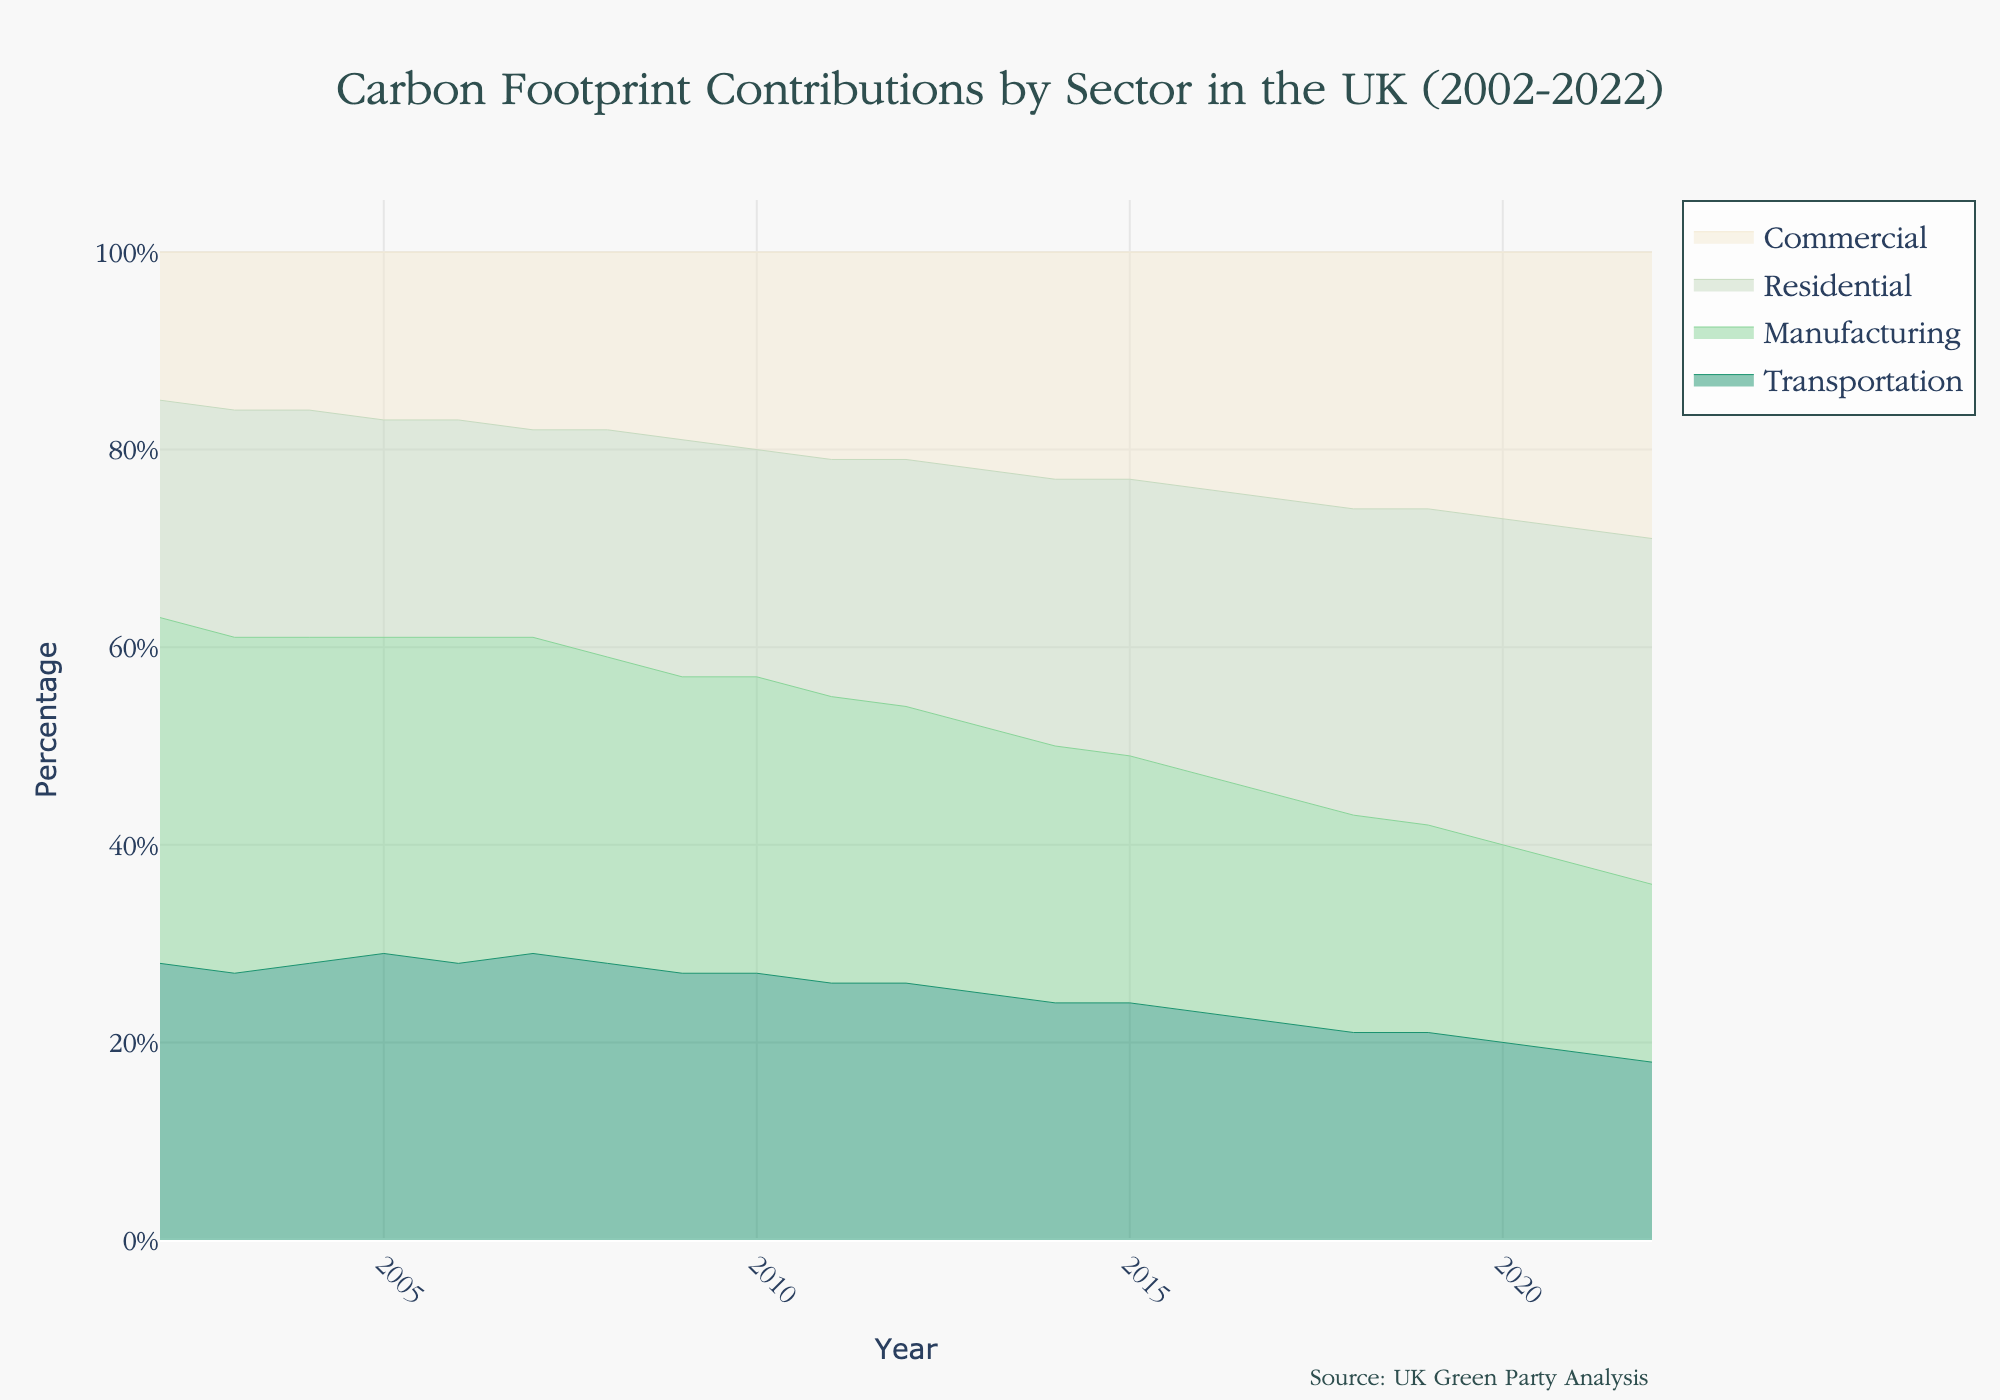what is the title of the figure? The title is displayed at the top center of the figure. It reads "Carbon Footprint Contributions by Sector in the UK (2002-2022)".
Answer: Carbon Footprint Contributions by Sector in the UK (2002-2022) What is the percentage of the Transportation sector in 2002? Locate the Transportation sector (the bottommost area) for the year 2002 on the x-axis. The height of this area relative to the total height is about 28%.
Answer: 28% Which sector showed the most considerable increase in contribution over the period? By observing the stacked areas from 2002 to 2022, the Residential sector shows a noticeable increase in its area, indicating a significant rise in its contribution.
Answer: Residential Between which years did the Manufacturing sector’s contribution drop the most? Look at the Manufacturing sector's area size across the years. The most significant drop occurs between 2005 (32%) and 2022 (18%).
Answer: 2005 to 2022 In which year did the Residential sector's percentage first surpass that of the Transportation sector? Track the crossover point where the area representing Residential becomes larger than Transportation. This happens in 2013.
Answer: 2013 What was the combined contribution of Commercial and Residential sectors in 2015? Add the individual percentages of the Commercial sector (23%) and Residential sector (28%) for 2015. The sum is 23% + 28% = 51%.
Answer: 51% How did the total contribution of all sectors in 2010 compare to that in 2015? Both years will sum to 100% as it is a 100% Stacked Area Chart. Thus, the total is the same.
Answer: The same Which sector had the smallest percentage contribution in 2022? The Commercial sector has a contribution of 29%, whereas the Manufacturing sector has the smallest contribution of 18%.
Answer: Manufacturing What trend is noticeable in the Transportation sector's contribution from 2002 to 2022? The Transportation sector's area shows a decreasing trend from 28% in 2002 to 18% in 2022.
Answer: Decreasing Between 2010 and 2020, how did the percentage contributions of the Commercial sector change? Compare the Commercial sector’s percentage in 2010 (20%) to that in 2020 (27%). The increase in contribution is 27% - 20% = 7%.
Answer: Increased by 7% 